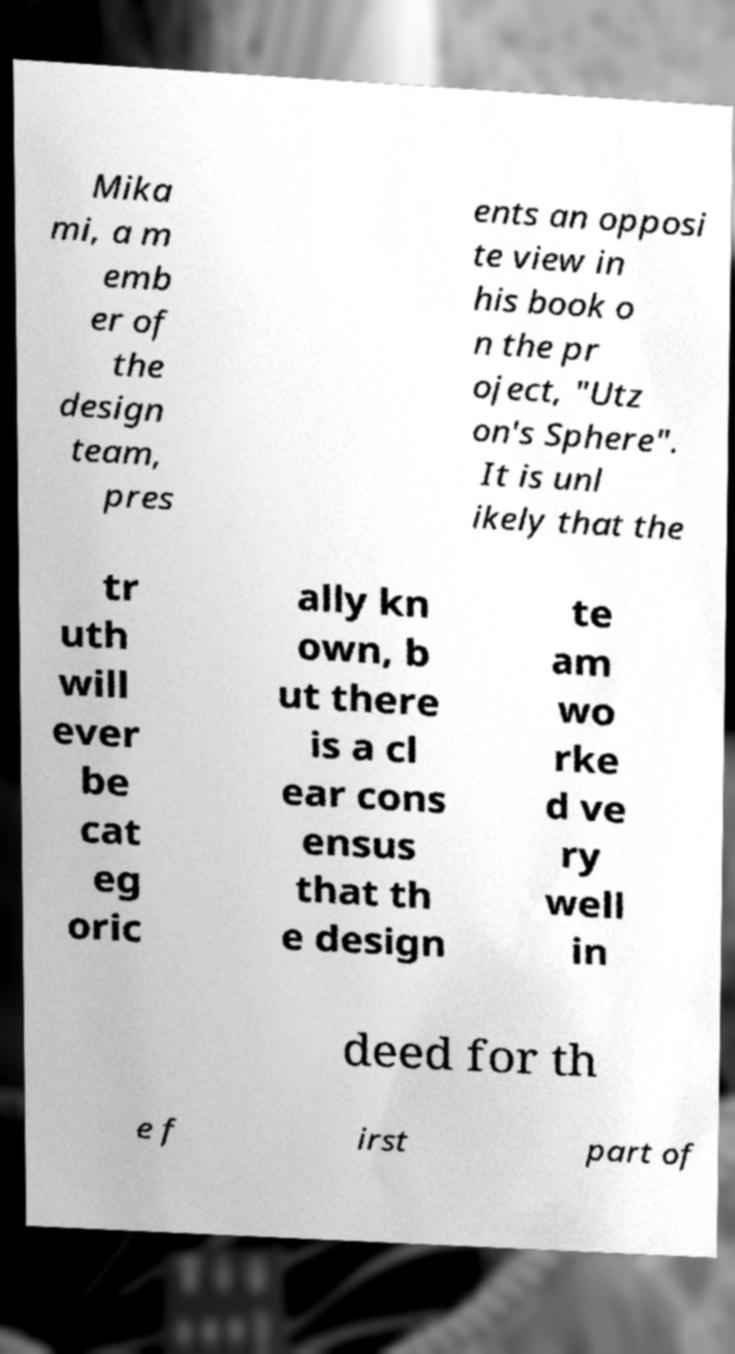Can you read and provide the text displayed in the image?This photo seems to have some interesting text. Can you extract and type it out for me? Mika mi, a m emb er of the design team, pres ents an opposi te view in his book o n the pr oject, "Utz on's Sphere". It is unl ikely that the tr uth will ever be cat eg oric ally kn own, b ut there is a cl ear cons ensus that th e design te am wo rke d ve ry well in deed for th e f irst part of 